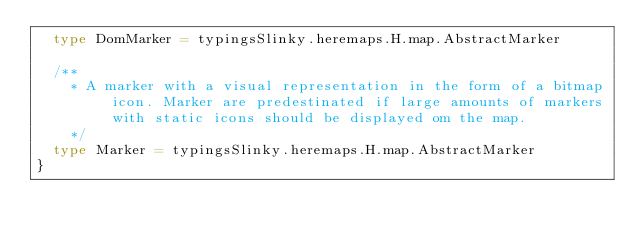<code> <loc_0><loc_0><loc_500><loc_500><_Scala_>  type DomMarker = typingsSlinky.heremaps.H.map.AbstractMarker
  
  /**
    * A marker with a visual representation in the form of a bitmap icon. Marker are predestinated if large amounts of markers with static icons should be displayed om the map.
    */
  type Marker = typingsSlinky.heremaps.H.map.AbstractMarker
}
</code> 